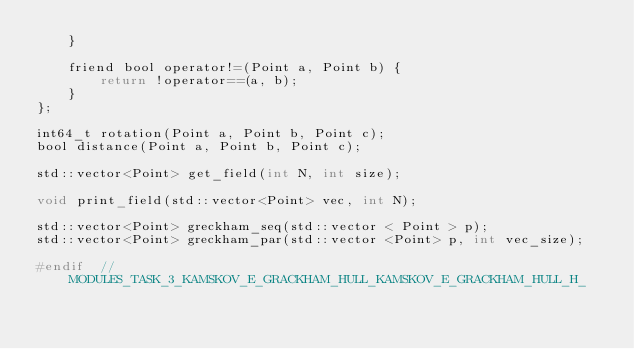<code> <loc_0><loc_0><loc_500><loc_500><_C_>    }

    friend bool operator!=(Point a, Point b) {
        return !operator==(a, b);
    }
};

int64_t rotation(Point a, Point b, Point c);
bool distance(Point a, Point b, Point c);

std::vector<Point> get_field(int N, int size);

void print_field(std::vector<Point> vec, int N);

std::vector<Point> greckham_seq(std::vector < Point > p);
std::vector<Point> greckham_par(std::vector <Point> p, int vec_size);

#endif  // MODULES_TASK_3_KAMSKOV_E_GRACKHAM_HULL_KAMSKOV_E_GRACKHAM_HULL_H_
</code> 